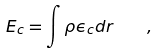Convert formula to latex. <formula><loc_0><loc_0><loc_500><loc_500>E _ { c } = \int \rho \epsilon _ { c } d { r } \quad ,</formula> 